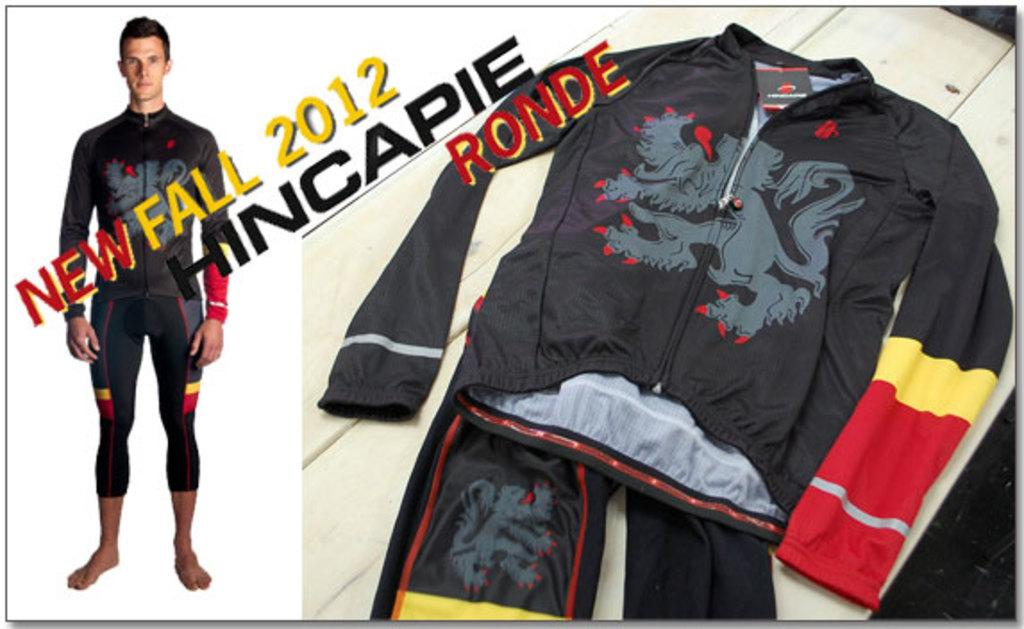<image>
Write a terse but informative summary of the picture. A New Fall 2012 catalog is displayed with a man wearing the items. 